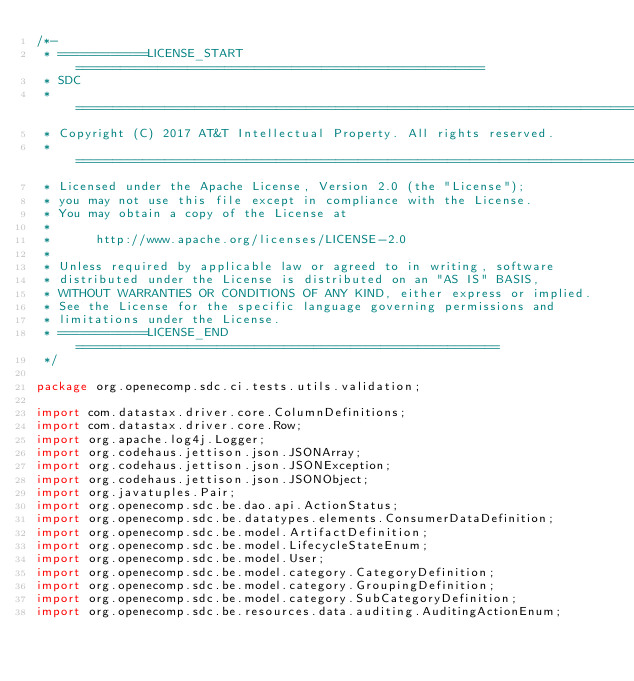Convert code to text. <code><loc_0><loc_0><loc_500><loc_500><_Java_>/*-
 * ============LICENSE_START=======================================================
 * SDC
 * ================================================================================
 * Copyright (C) 2017 AT&T Intellectual Property. All rights reserved.
 * ================================================================================
 * Licensed under the Apache License, Version 2.0 (the "License");
 * you may not use this file except in compliance with the License.
 * You may obtain a copy of the License at
 * 
 *      http://www.apache.org/licenses/LICENSE-2.0
 * 
 * Unless required by applicable law or agreed to in writing, software
 * distributed under the License is distributed on an "AS IS" BASIS,
 * WITHOUT WARRANTIES OR CONDITIONS OF ANY KIND, either express or implied.
 * See the License for the specific language governing permissions and
 * limitations under the License.
 * ============LICENSE_END=========================================================
 */

package org.openecomp.sdc.ci.tests.utils.validation;

import com.datastax.driver.core.ColumnDefinitions;
import com.datastax.driver.core.Row;
import org.apache.log4j.Logger;
import org.codehaus.jettison.json.JSONArray;
import org.codehaus.jettison.json.JSONException;
import org.codehaus.jettison.json.JSONObject;
import org.javatuples.Pair;
import org.openecomp.sdc.be.dao.api.ActionStatus;
import org.openecomp.sdc.be.datatypes.elements.ConsumerDataDefinition;
import org.openecomp.sdc.be.model.ArtifactDefinition;
import org.openecomp.sdc.be.model.LifecycleStateEnum;
import org.openecomp.sdc.be.model.User;
import org.openecomp.sdc.be.model.category.CategoryDefinition;
import org.openecomp.sdc.be.model.category.GroupingDefinition;
import org.openecomp.sdc.be.model.category.SubCategoryDefinition;
import org.openecomp.sdc.be.resources.data.auditing.AuditingActionEnum;</code> 